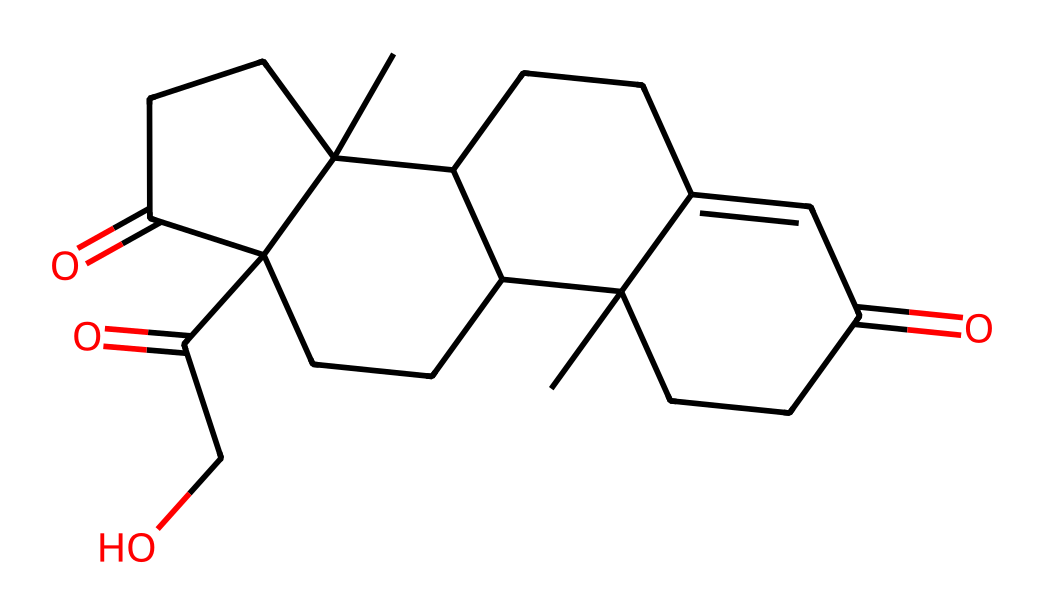What is the molecular formula of cortisone? To determine the molecular formula, we need to count the number of each type of atom represented in the SMILES notation. The structure includes carbon (C), hydrogen (H), and oxygen (O) atoms. Examining the SMILES reveals there are 21 carbon atoms, 28 hydrogen atoms, and 5 oxygen atoms. Therefore, the molecular formula is C21H28O5.
Answer: C21H28O5 How many rings are present in the cortisone structure? The SMILES representation shows a complex structure with multiple cyclic components. By analyzing the notation, we can see that there are four distinct ring closures indicated by the numbers. Each number represents a point where the chain connects back to an earlier atom, indicating that there are four rings in total in the structure.
Answer: 4 Is cortisone a steroid? Cortisone is characterized as a steroid based on its chemical structure, which includes a steroid nucleus. This nucleus features a specific configuration of four fused carbon rings, typical of steroids. Thus, it is correctly classified as a steroid compound.
Answer: Yes What type of functional groups are present in cortisone? In analyzing the chemical makeup, we identify certain functional groups based on the presence of specific atom arrangements. The SMILES shows ketone groups (C=O) and an alcohol group (C-OH). These functional groups contribute to the biochemical activity of cortisone as an anti-inflammatory agent.
Answer: Ketones and alcohol What is the significance of cortisone's ketone groups in its function? Ketones play a critical role in cortisone’s mechanism, influencing its solubility and biological activity. They help cortisone bind effectively to cortisol receptors, modulating inflammatory responses. This is essential for its use in inflammation treatment, thus underlining the importance of these functional groups in the drug's efficacy.
Answer: Modulation of inflammation How does the structure of cortisone contribute to its therapeutic effects? The three-dimensional arrangement of cortisone, particularly the presence of the hydrophobic and hydrophilic functional groups, affects its interaction with receptors and biological systems. The steroid structure allows for effective binding to corticosteroid receptors in cells, which results in decreased inflammation and immune response. This structure-function relationship is crucial for its efficacy as a therapeutic compound.
Answer: Structural interaction with receptors 